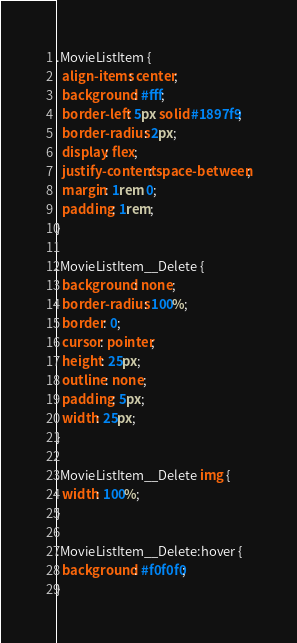<code> <loc_0><loc_0><loc_500><loc_500><_CSS_>.MovieListItem {
  align-items: center;
  background: #fff;
  border-left: 5px solid #1897f9;
  border-radius: 2px;
  display: flex;
  justify-content: space-between;
  margin: 1rem 0;
  padding: 1rem;
}

.MovieListItem__Delete {
  background: none;
  border-radius: 100%;
  border: 0;
  cursor: pointer;
  height: 25px;
  outline: none;
  padding: 5px;
  width: 25px;
}

.MovieListItem__Delete img {
  width: 100%;
}

.MovieListItem__Delete:hover {
  background: #f0f0f0;
}</code> 